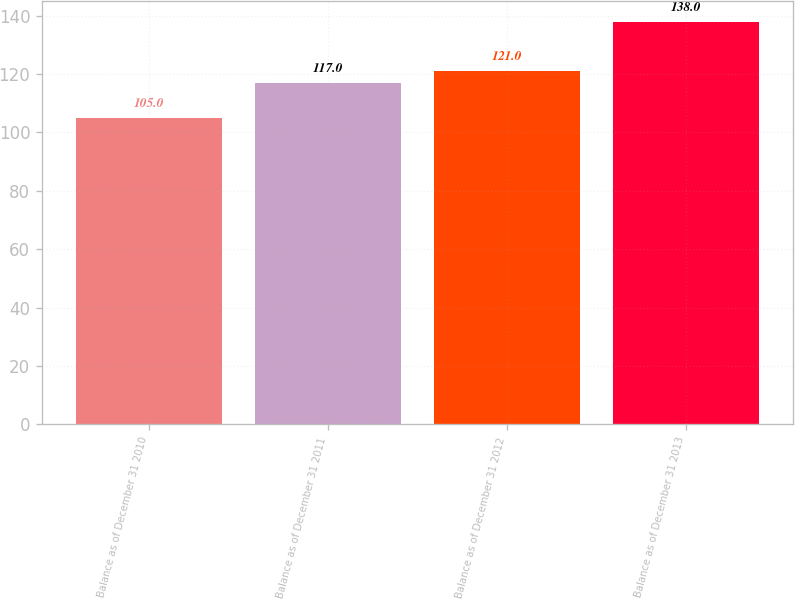Convert chart to OTSL. <chart><loc_0><loc_0><loc_500><loc_500><bar_chart><fcel>Balance as of December 31 2010<fcel>Balance as of December 31 2011<fcel>Balance as of December 31 2012<fcel>Balance as of December 31 2013<nl><fcel>105<fcel>117<fcel>121<fcel>138<nl></chart> 